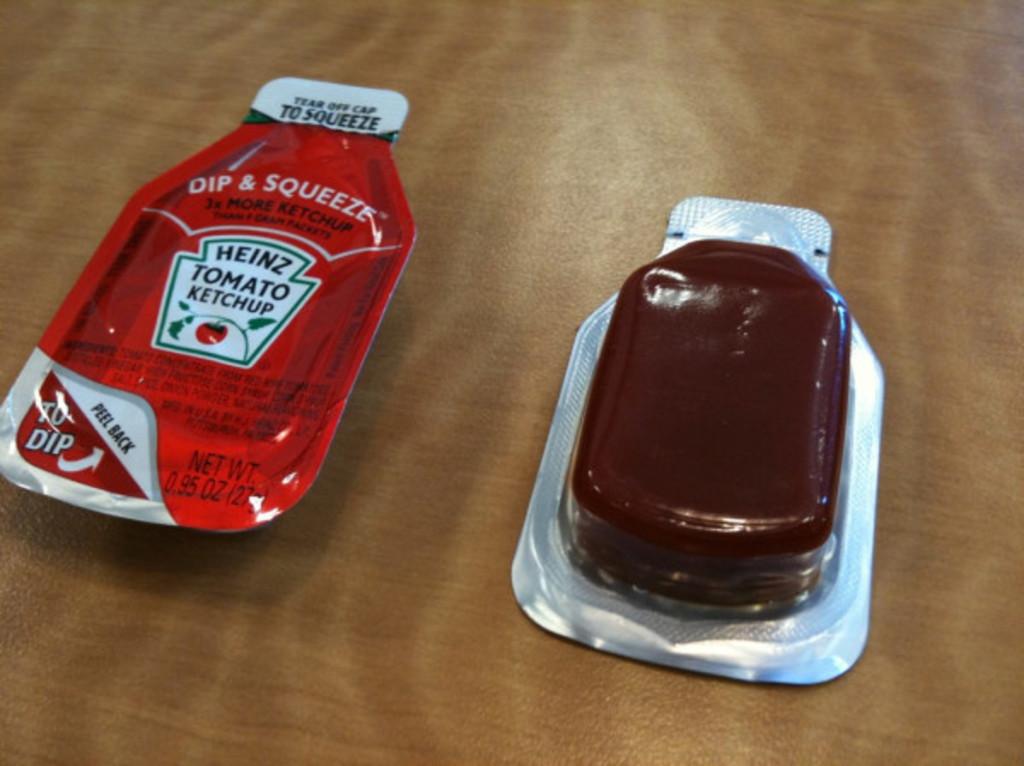What type of heinz product is that?
Provide a short and direct response. Ketchup. 